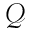Convert formula to latex. <formula><loc_0><loc_0><loc_500><loc_500>\mathcal { Q }</formula> 